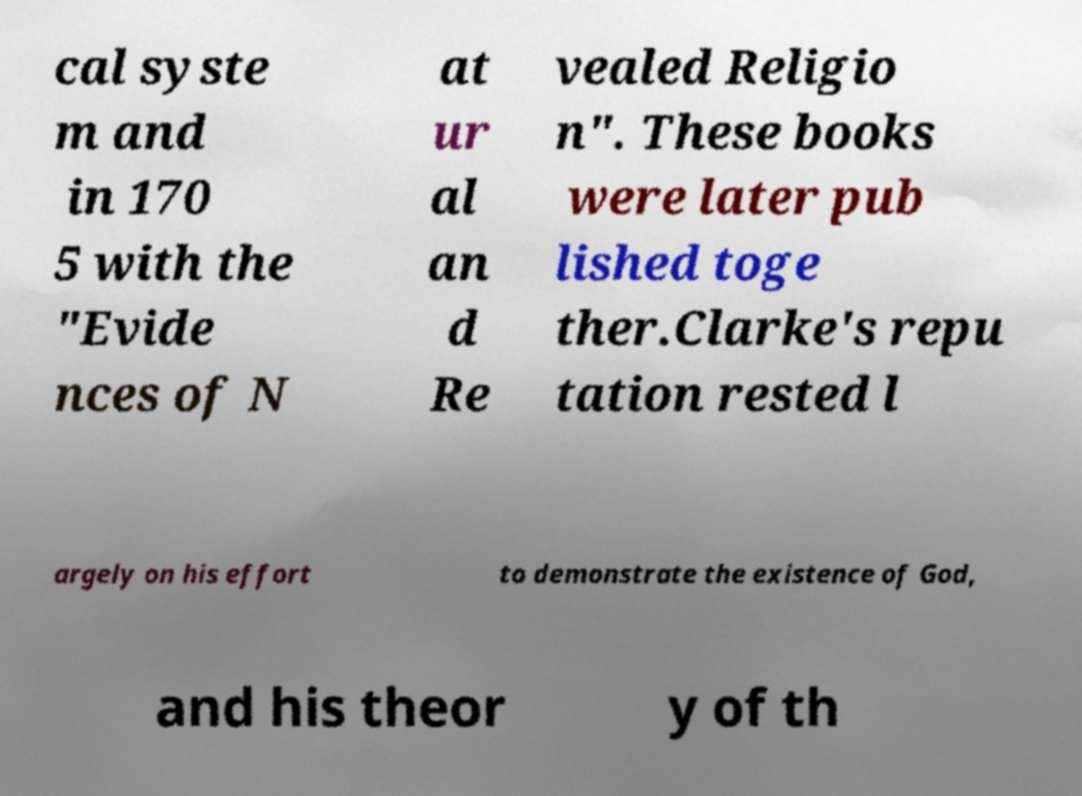Could you extract and type out the text from this image? cal syste m and in 170 5 with the "Evide nces of N at ur al an d Re vealed Religio n". These books were later pub lished toge ther.Clarke's repu tation rested l argely on his effort to demonstrate the existence of God, and his theor y of th 